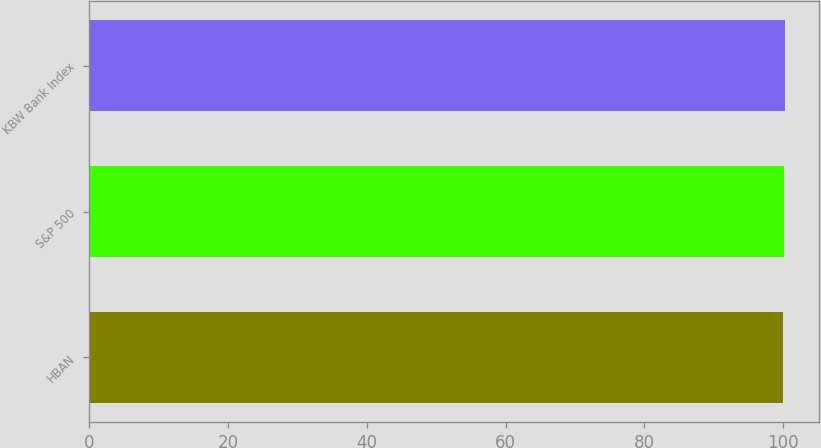Convert chart. <chart><loc_0><loc_0><loc_500><loc_500><bar_chart><fcel>HBAN<fcel>S&P 500<fcel>KBW Bank Index<nl><fcel>100<fcel>100.1<fcel>100.2<nl></chart> 